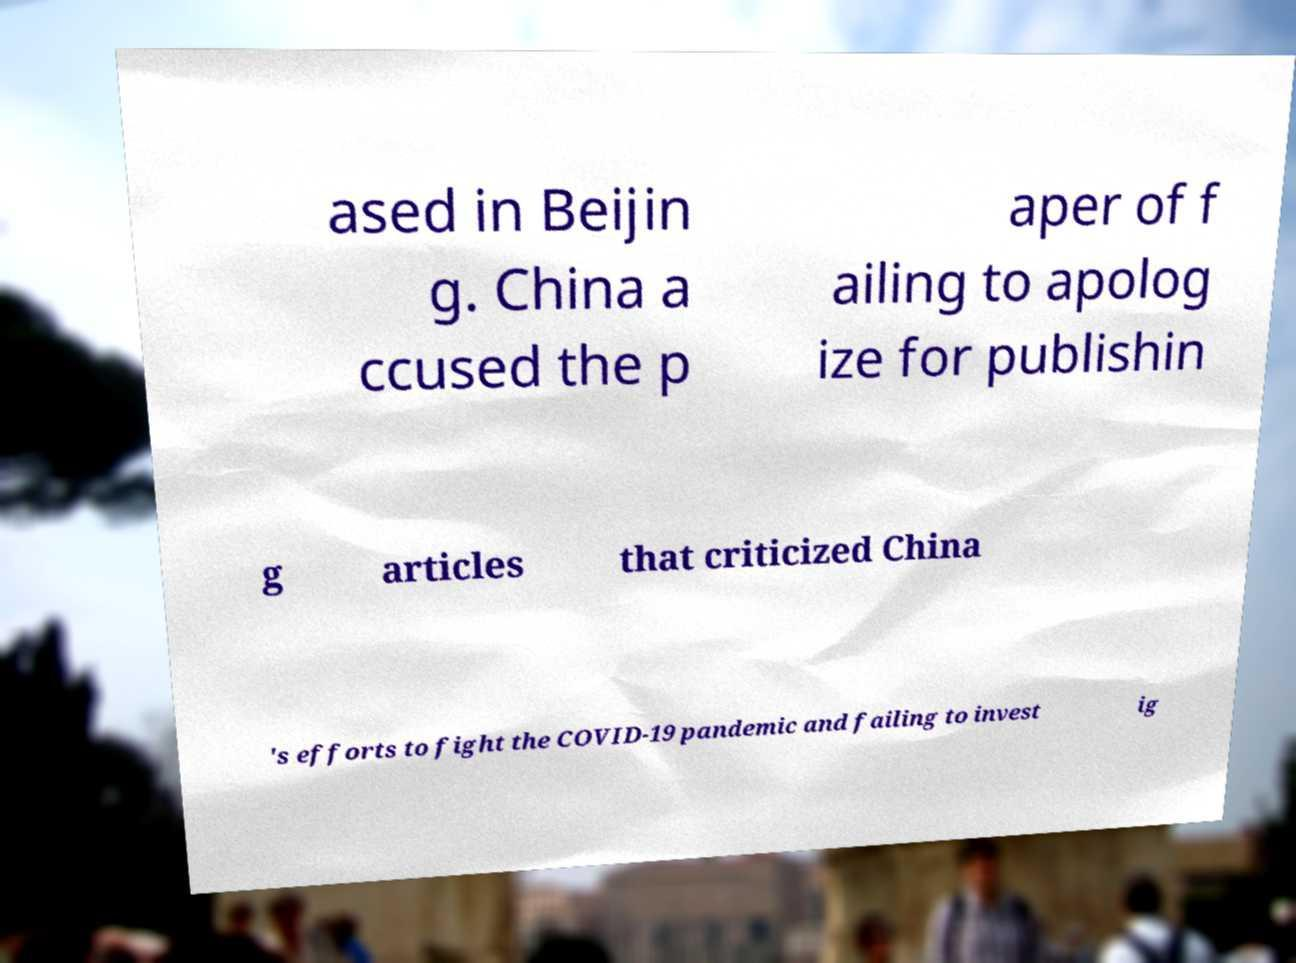There's text embedded in this image that I need extracted. Can you transcribe it verbatim? ased in Beijin g. China a ccused the p aper of f ailing to apolog ize for publishin g articles that criticized China 's efforts to fight the COVID-19 pandemic and failing to invest ig 